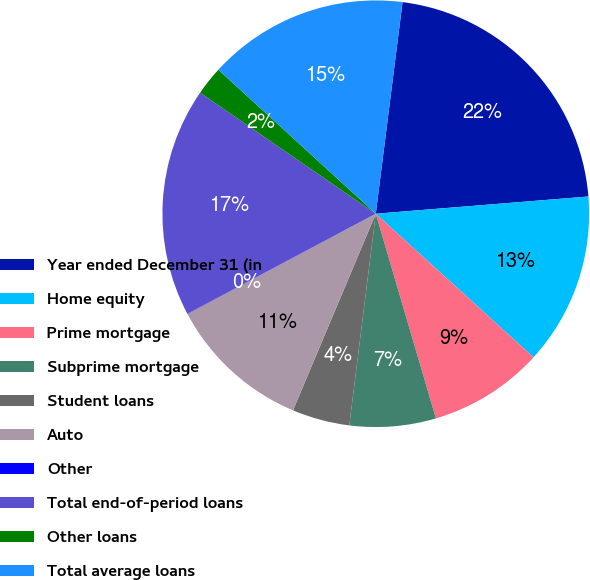Convert chart. <chart><loc_0><loc_0><loc_500><loc_500><pie_chart><fcel>Year ended December 31 (in<fcel>Home equity<fcel>Prime mortgage<fcel>Subprime mortgage<fcel>Student loans<fcel>Auto<fcel>Other<fcel>Total end-of-period loans<fcel>Other loans<fcel>Total average loans<nl><fcel>21.71%<fcel>13.04%<fcel>8.7%<fcel>6.53%<fcel>4.36%<fcel>10.87%<fcel>0.02%<fcel>17.37%<fcel>2.19%<fcel>15.21%<nl></chart> 